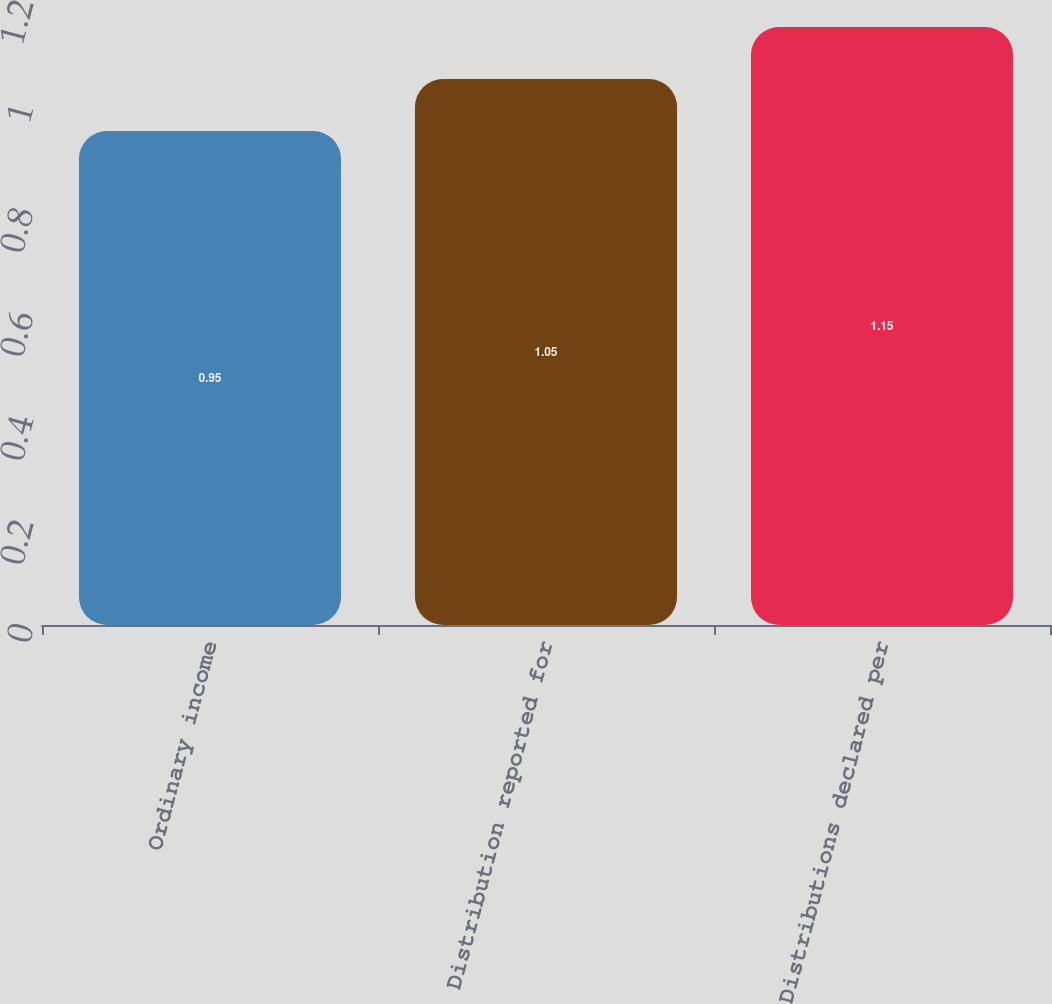Convert chart. <chart><loc_0><loc_0><loc_500><loc_500><bar_chart><fcel>Ordinary income<fcel>Distribution reported for<fcel>Distributions declared per<nl><fcel>0.95<fcel>1.05<fcel>1.15<nl></chart> 